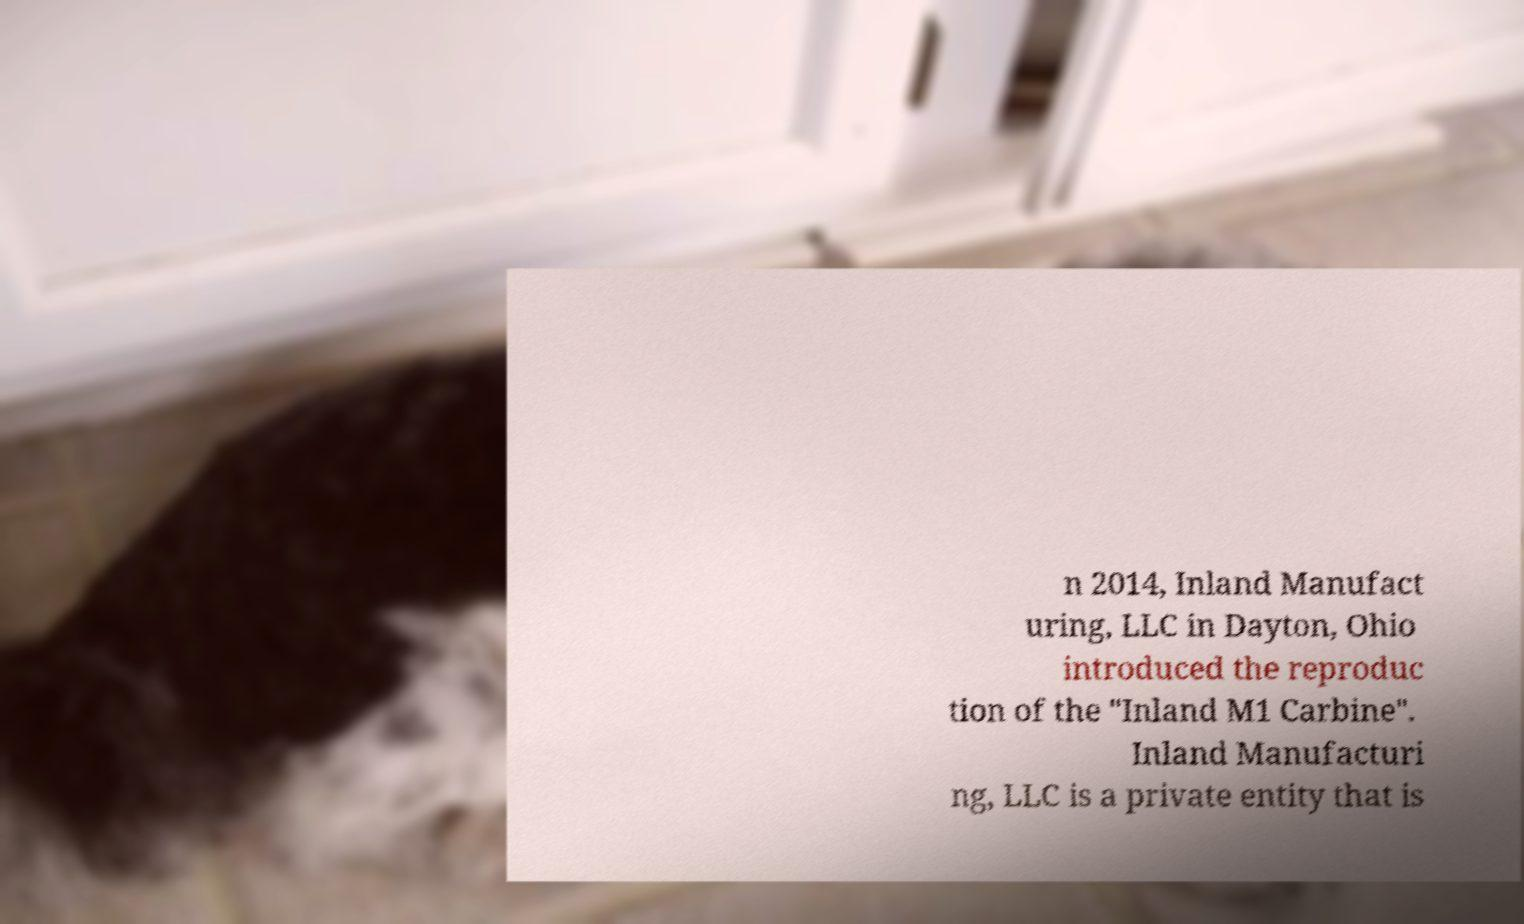I need the written content from this picture converted into text. Can you do that? n 2014, Inland Manufact uring, LLC in Dayton, Ohio introduced the reproduc tion of the "Inland M1 Carbine". Inland Manufacturi ng, LLC is a private entity that is 